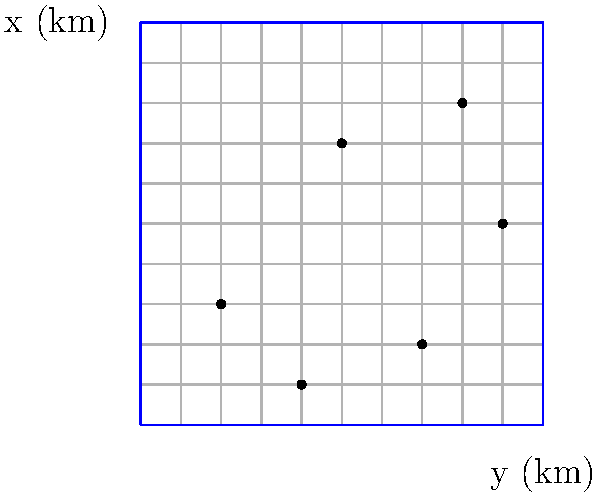As a seasoned bird watcher conducting an aerial survey, you observe the distribution of a rare bird species in a 10 km × 10 km area, as shown in the grid above. Each dot represents a bird sighting. Using the quadrat method, if you divide the area into four equal quadrats, what is the estimated population density of this bird species per square kilometer? To solve this problem, we'll follow these steps:

1. Divide the area into four equal quadrats:
   The 10 km × 10 km area can be divided into four 5 km × 5 km quadrats.

2. Count the number of birds in each quadrat:
   - Top-left quadrat: 1 bird
   - Top-right quadrat: 2 birds
   - Bottom-left quadrat: 2 birds
   - Bottom-right quadrat: 1 bird

3. Calculate the total number of birds:
   Total birds = 1 + 2 + 2 + 1 = 6 birds

4. Calculate the average number of birds per quadrat:
   Average birds per quadrat = Total birds ÷ Number of quadrats
   = 6 ÷ 4 = 1.5 birds per quadrat

5. Calculate the area of each quadrat:
   Quadrat area = 5 km × 5 km = 25 km²

6. Calculate the population density:
   Density = Average birds per quadrat ÷ Quadrat area
   = 1.5 ÷ 25 = 0.06 birds/km²

Therefore, the estimated population density is 0.06 birds per square kilometer.
Answer: 0.06 birds/km² 